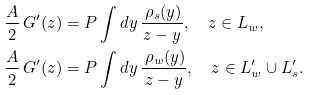Convert formula to latex. <formula><loc_0><loc_0><loc_500><loc_500>\frac { A } { 2 } \, G ^ { \prime } ( z ) & = P \int d y \, \frac { \, \rho _ { s } ( y ) } { z - y } , \quad z \in L _ { w } , \\ \frac { A } { 2 } \, G ^ { \prime } ( z ) & = P \int d y \, \frac { \, \rho _ { w } ( y ) } { z - y } , \quad z \in L ^ { \prime } _ { w } \cup L ^ { \prime } _ { s } .</formula> 